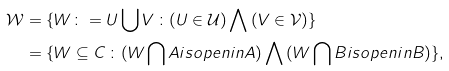Convert formula to latex. <formula><loc_0><loc_0><loc_500><loc_500>\mathcal { W } & = \{ W \colon = U \, { \bigcup } \, V \, \colon ( U \in \mathcal { U } ) \, { \bigwedge } \, ( V \in \mathcal { V } ) \} \\ & = \{ W \subseteq C \, \colon ( W \, { \bigcap } \, A i s o p e n i n A ) \, { \bigwedge } \, ( W \, { \bigcap } \, B i s o p e n i n B ) \} ,</formula> 